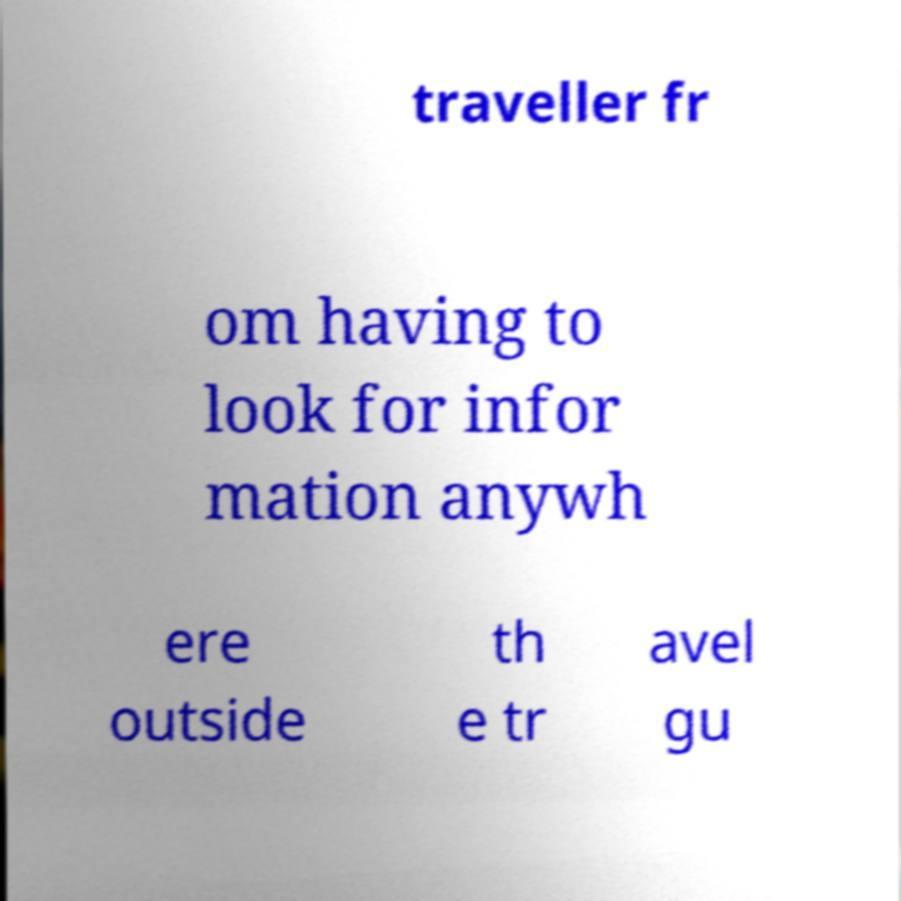For documentation purposes, I need the text within this image transcribed. Could you provide that? traveller fr om having to look for infor mation anywh ere outside th e tr avel gu 